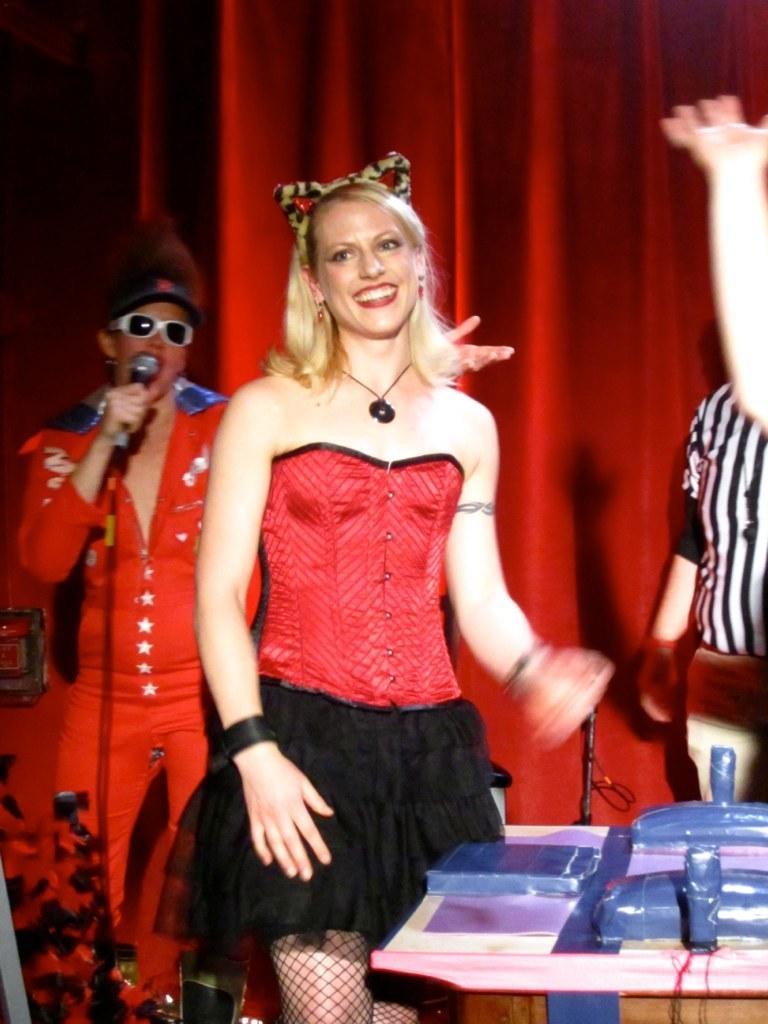Please provide a concise description of this image. Here I can see a woman standing and smiling. On the left side there is another person wearing red color dress, standing, holding a mike in the hand and it seems like singing. In the bottom right-hand corner there is a table on which few objects are placed. Behind the table there is a person standing and also I can see another person's hand. In the background there is a red color curtain. 